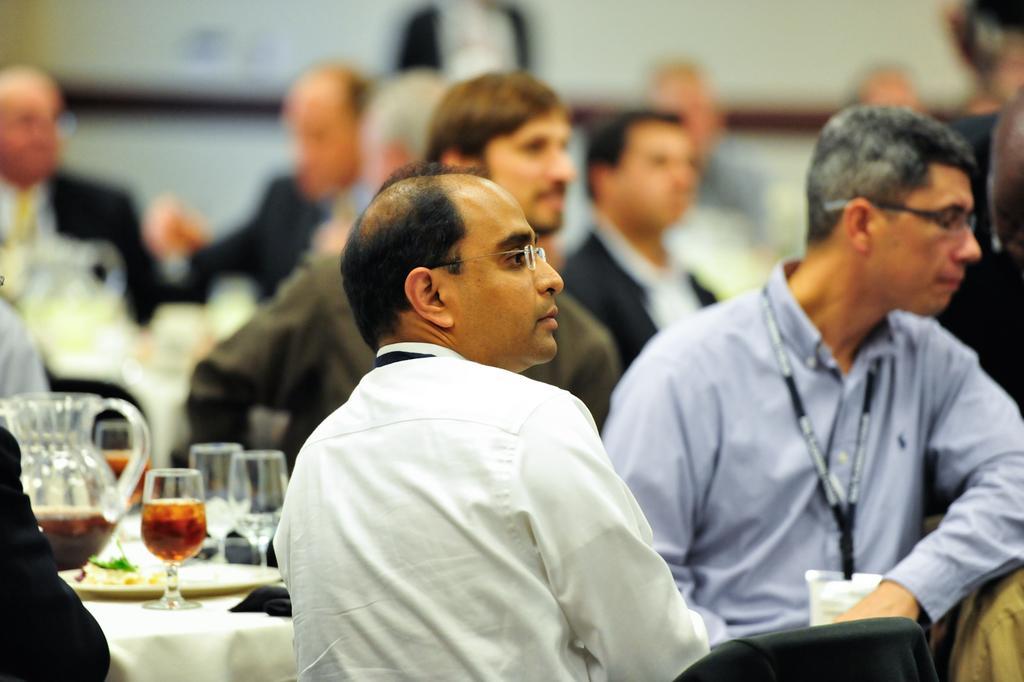How would you summarize this image in a sentence or two? In this image we can see group of persons sitting on the chair. In front of table. One person is wearing white shirt and spectacles is sitting on a chair. On the table we can see a jug and group of glass ,plates placed on the table. In the background,we can see group of persons standing. 